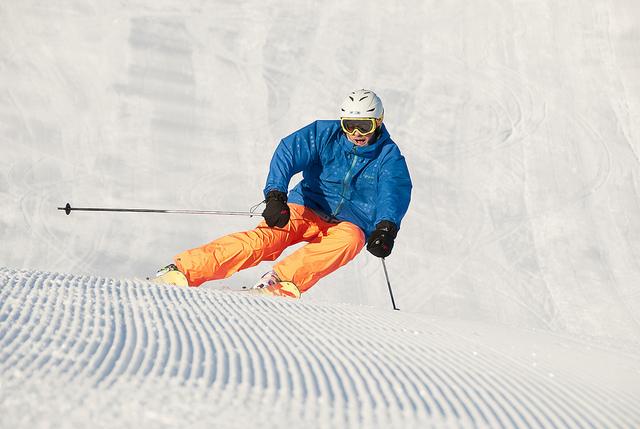Where does this story take place?
Write a very short answer. Mountains. What is the man doing?
Short answer required. Skiing. What sport is the man participating in?
Write a very short answer. Skiing. What is the person standing on?
Be succinct. Skis. What color are his snow pants?
Be succinct. Orange. 